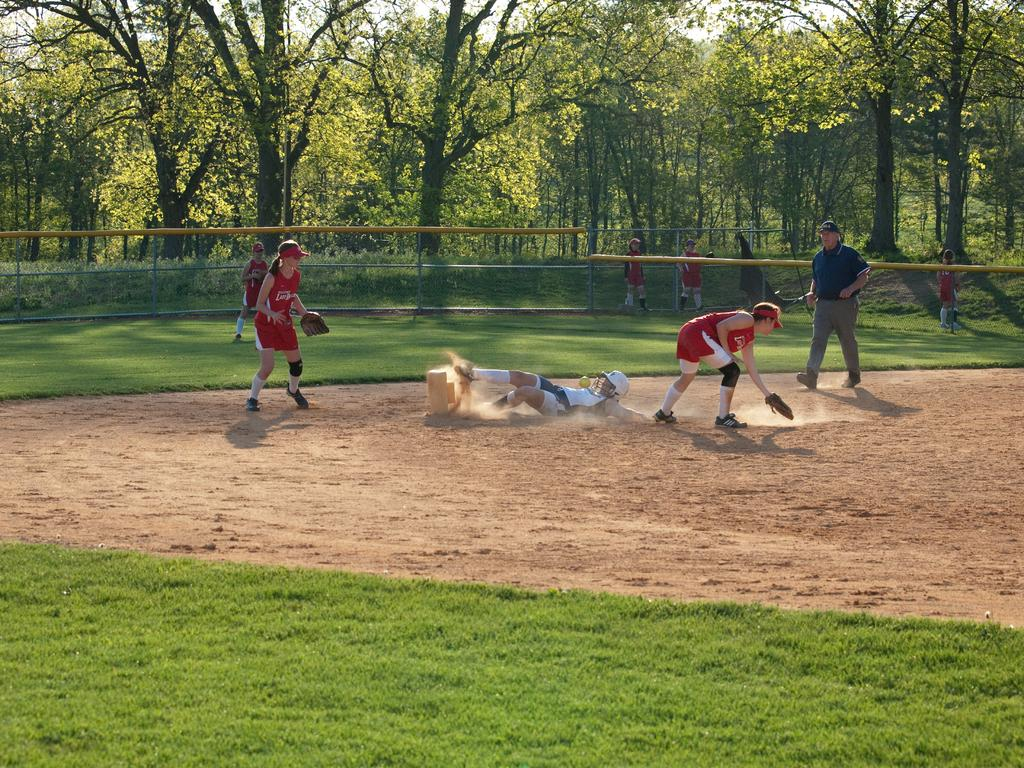What is happening in the center of the image? There are persons on the ground in the center of the image. What can be seen in the background of the image? There is fencing, persons, trees, and the sky visible in the background of the image. What type of terrain is present at the bottom of the image? There is grass at the bottom of the image. Can you see any bananas being shaken by a rat in the image? There is no rat or banana present in the image. 